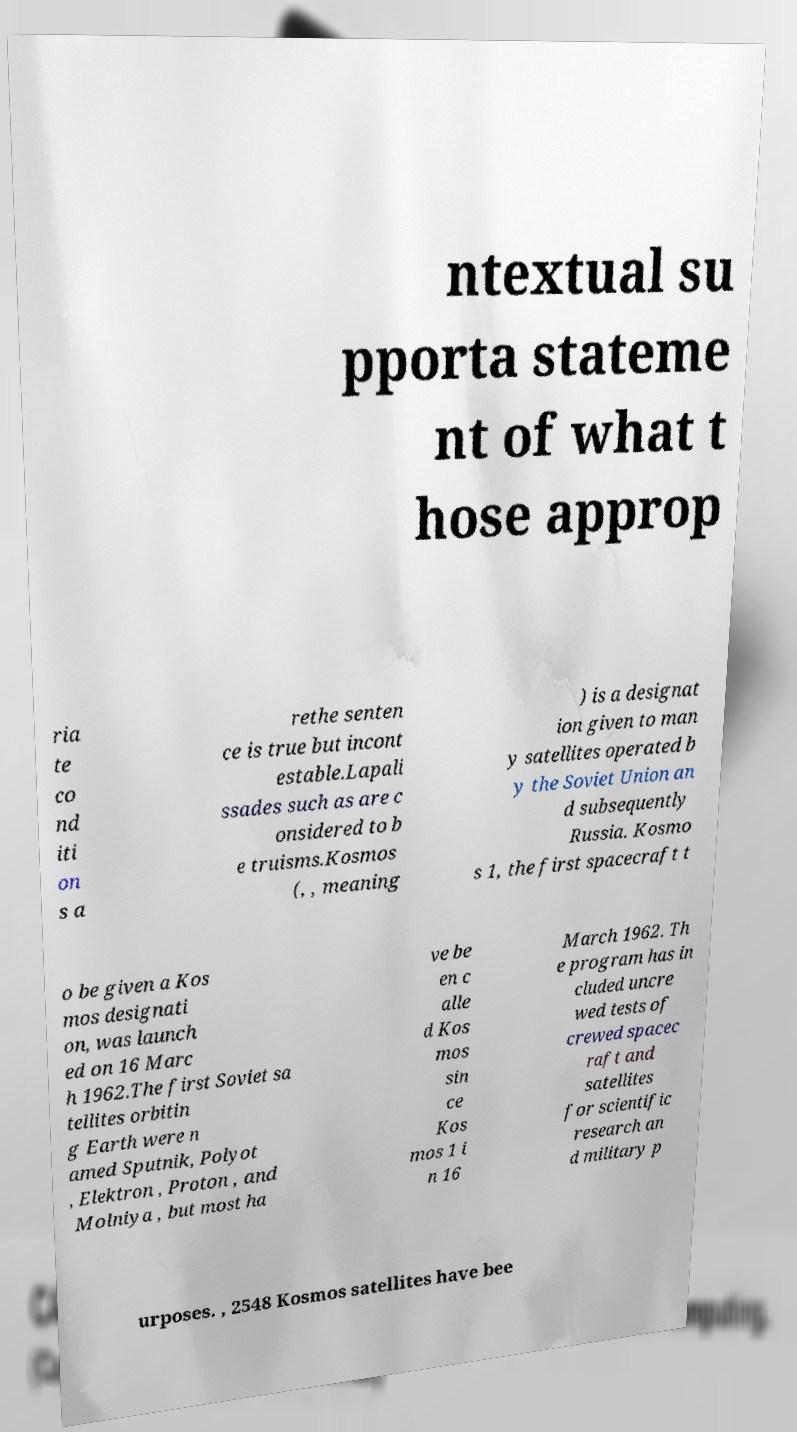Can you accurately transcribe the text from the provided image for me? ntextual su pporta stateme nt of what t hose approp ria te co nd iti on s a rethe senten ce is true but incont estable.Lapali ssades such as are c onsidered to b e truisms.Kosmos (, , meaning ) is a designat ion given to man y satellites operated b y the Soviet Union an d subsequently Russia. Kosmo s 1, the first spacecraft t o be given a Kos mos designati on, was launch ed on 16 Marc h 1962.The first Soviet sa tellites orbitin g Earth were n amed Sputnik, Polyot , Elektron , Proton , and Molniya , but most ha ve be en c alle d Kos mos sin ce Kos mos 1 i n 16 March 1962. Th e program has in cluded uncre wed tests of crewed spacec raft and satellites for scientific research an d military p urposes. , 2548 Kosmos satellites have bee 